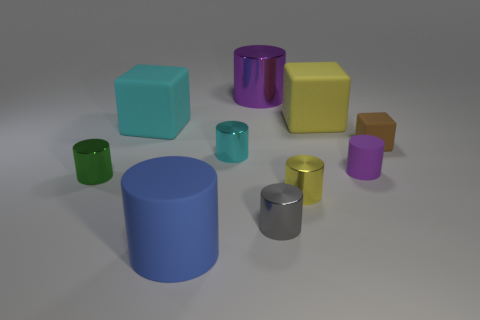What is the texture and appearance of the objects? Do they seem to be made from the same material? The objects in the image have a smooth, matte texture, suggesting they may be made of a material like rubber or a matte plastic. The uniformly diffused lighting on the surfaces and lack of any shiny reflections support this observation. While all objects share a similar texture, their varied colors give each a distinct appearance. 